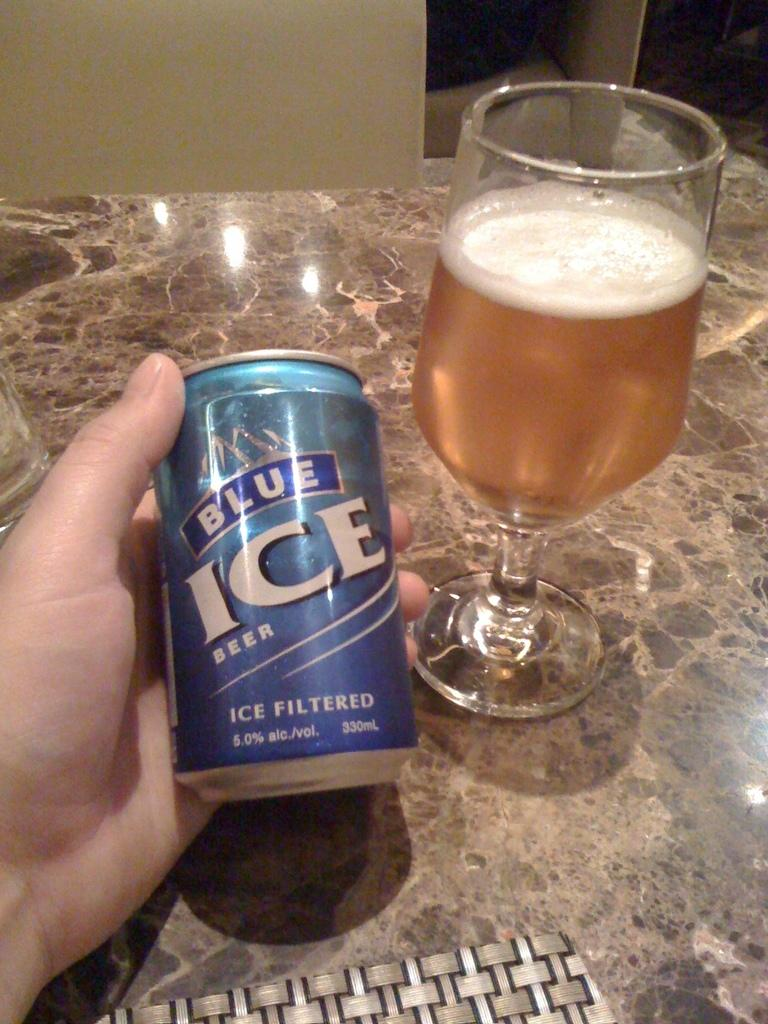<image>
Describe the image concisely. A hand holding a can of Blue Ice beer next to a glass of beer. 